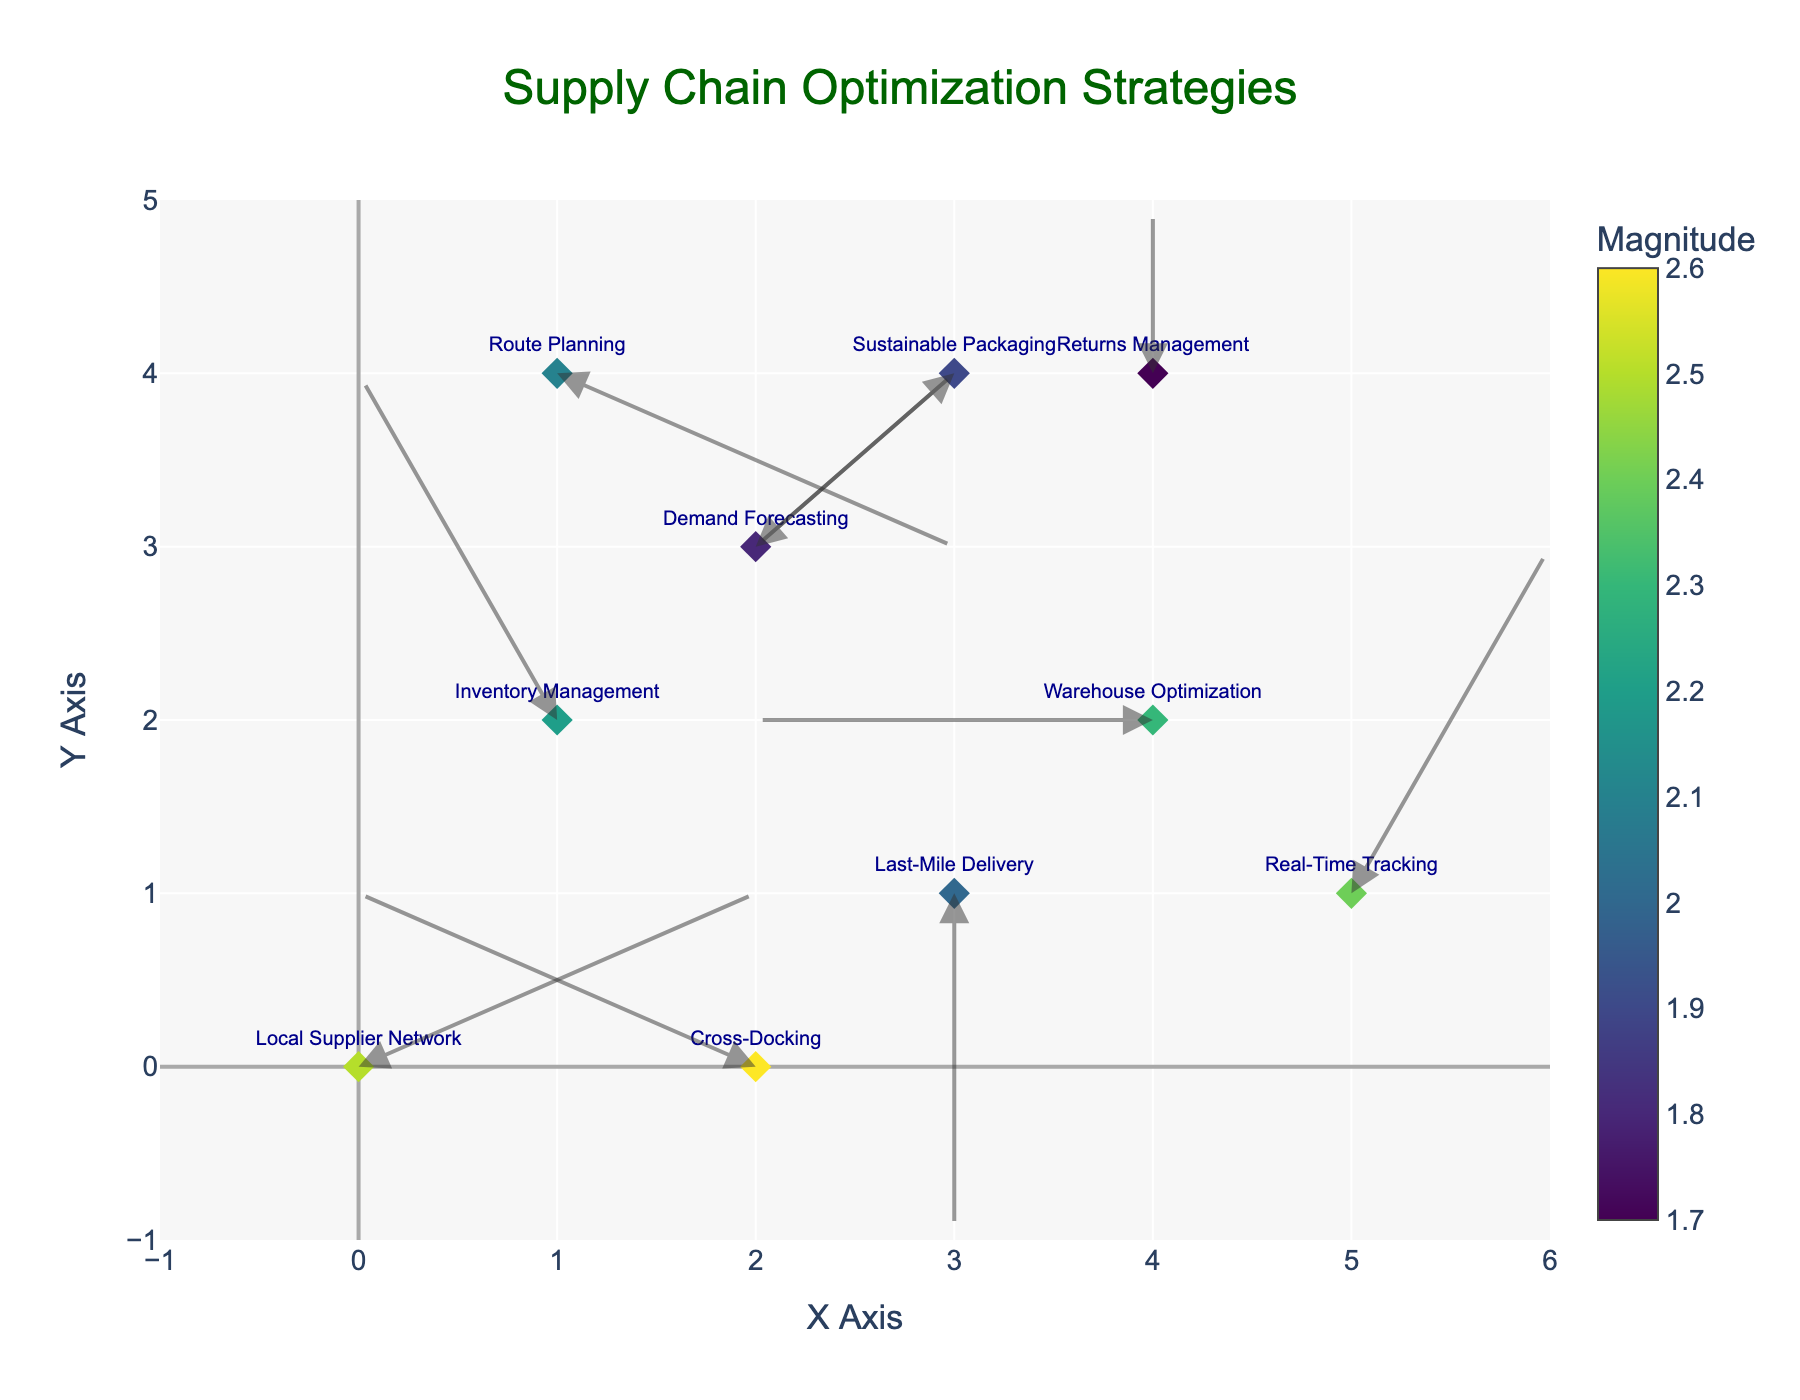What is the title of the plot? The title is displayed at the top of the plot. It reads 'Supply Chain Optimization Strategies' in dark green font.
Answer: Supply Chain Optimization Strategies How many data points are in the plot? Count the number of arrows or markers depicted in the plot. Each point has a corresponding label. There are 10 distinct data points.
Answer: 10 Which label has the highest magnitude value, and what is it? Look at the colors and the color bar. The darkest diamond represents the highest magnitude value, which is 2.6. The corresponding label is "Cross-Docking".
Answer: Cross-Docking, 2.6 What is the direction and magnitude of 'Last-Mile Delivery'? Find the label 'Last-Mile Delivery' and check the corresponding arrow and magnitude. The vector is (0, -2) with a magnitude of 2.0, indicating a downward direction.
Answer: Down, 2.0 Which label shows movement towards negative values on both x and y axes? Locate the labels with arrows pointing left-down. 'Sustainable Packaging' is the label with an arrow in the (-1, -1) direction.
Answer: Sustainable Packaging Compare the magnitude of 'Warehouse Optimization' and 'Route Planning'. Which one is larger? Check the color intensity and the color bar values. 'Warehouse Optimization' has a magnitude of 2.3, whereas 'Route Planning' has 2.1. Therefore, 'Warehouse Optimization' is larger.
Answer: Warehouse Optimization Which labels have an arrow component in the positive x-direction? Identify the labels with arrows pointing to the right (positive x-direction component). 'Local Supplier Network', 'Demand Forecasting', 'Route Planning', and 'Real-Time Tracking' fit this criterion.
Answer: Local Supplier Network, Demand Forecasting, Route Planning, Real-Time Tracking What is the average magnitude of all data points? Sum all the magnitude values: 2.5 + 2.2 + 2.0 + 1.8 + 2.3 + 2.1 + 1.9 + 2.4 + 1.7 + 2.6 = 21.5. Divide by the number of data points (10).
Answer: 2.15 Which label is represented by the arrow starting at (4,2) and what is its vector? Locate the arrow that begins at (4,2). The label at this position is 'Warehouse Optimization', and its vector is (-2, 0).
Answer: Warehouse Optimization, (-2, 0) 